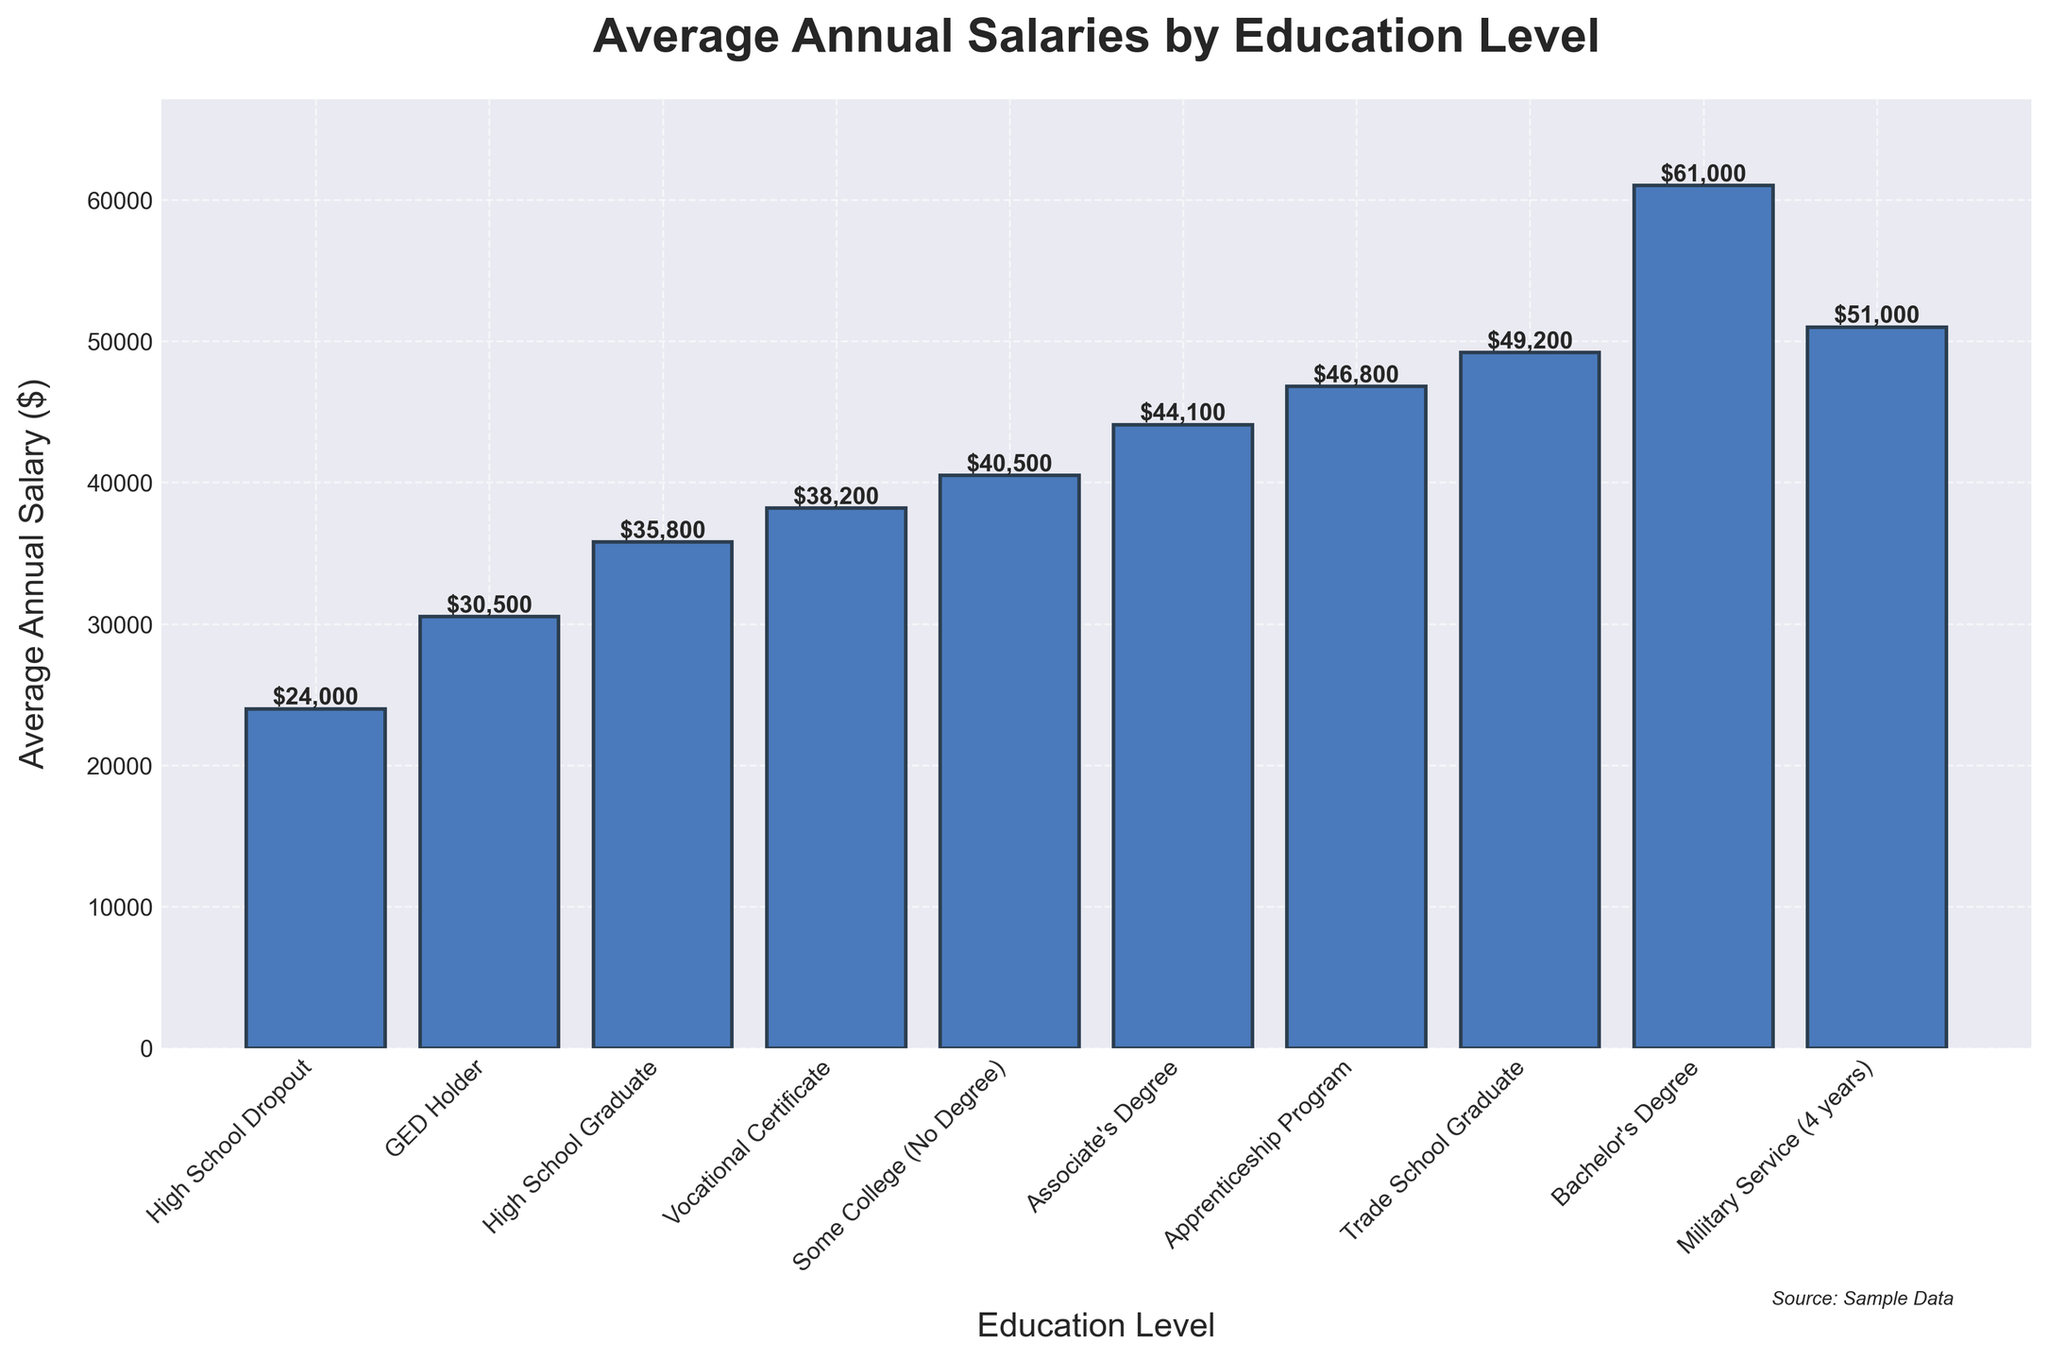What's the average annual salary for GED Holders? Looking at the bar corresponding to "GED Holder," the label on top of the bar shows $30,500.
Answer: $30,500 Which education level has the highest average annual salary? By examining the height of the bars and their labels, "Bachelor's Degree" has the highest bar with a value of $61,000.
Answer: Bachelor's Degree How much more does a Trade School Graduate earn annually on average compared to a High School Graduate? The bar for "Trade School Graduate" is labeled $49,200, and the bar for "High School Graduate" is labeled $35,800. The difference is $49,200 - $35,800 = $13,400.
Answer: $13,400 Which education levels have an average annual salary below $45,000? Identifying the bars and labels below $45,000, the education levels are: "High School Dropout," "GED Holder," "High School Graduate," "Vocational Certificate," and "Some College (No Degree)."
Answer: High School Dropout, GED Holder, High School Graduate, Vocational Certificate, Some College (No Degree) Between a Vocational Certificate and an Associate's Degree, which one has a higher average salary and by how much? The bar for "Associate's Degree" shows $44,100, and the bar for "Vocational Certificate" shows $38,200. The difference is $44,100 - $38,200 = $5,900.
Answer: Associate’s Degree by $5,900 What is the average annual salary difference between the lowest and highest education levels represented on the chart? The lowest annual salary is for "High School Dropout" at $24,000, and the highest is for "Bachelor's Degree" at $61,000. The difference is $61,000 - $24,000 = $37,000.
Answer: $37,000 Compare the average annual salary of Military Service (4 years) to an Apprenticeship Program. Which one is higher, and by what amount? The bar labeled "Military Service (4 years)" shows $51,000, and "Apprenticeship Program" shows $46,800. The difference is $51,000 - $46,800 = $4,200, indicating Military Service is higher.
Answer: Military Service by $4,200 List the education levels whose average annual salary exceeds $40,000 but is less than $50,000. The bars corresponding to this range are "Some College (No Degree)" at $40,500, "Associate's Degree" at $44,100, and "Apprenticeship Program" at $46,800.
Answer: Some College (No Degree), Associate’s Degree, Apprenticeship Program What is the combined average annual salary for a High School Dropout and a GED Holder? The bar for "High School Dropout" is $24,000 and for "GED Holder" is $30,500. Adding them gives $24,000 + $30,500 = $54,500.
Answer: $54,500 